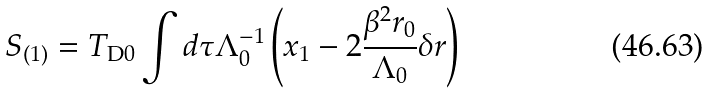<formula> <loc_0><loc_0><loc_500><loc_500>S _ { ( 1 ) } = T _ { \text {D} 0 } \int d \tau \Lambda _ { 0 } ^ { - 1 } \left ( x _ { 1 } - 2 \frac { \beta ^ { 2 } r _ { 0 } } { \Lambda _ { 0 } } \delta r \right )</formula> 